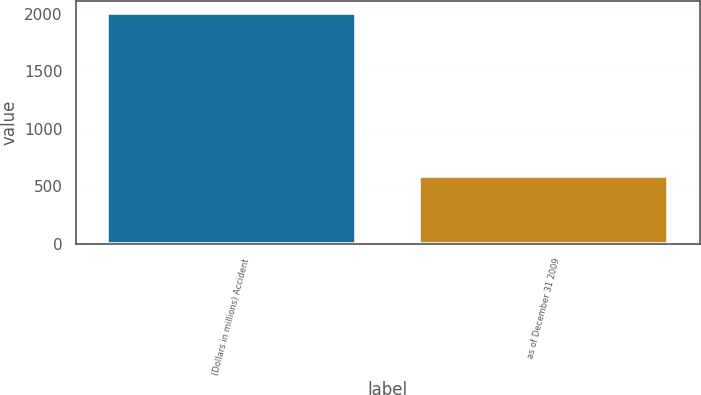<chart> <loc_0><loc_0><loc_500><loc_500><bar_chart><fcel>(Dollars in millions) Accident<fcel>as of December 31 2009<nl><fcel>2009<fcel>591<nl></chart> 